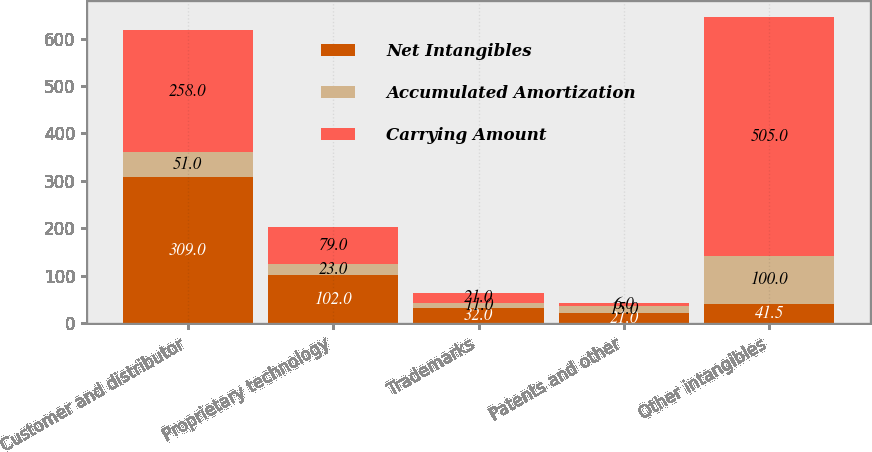Convert chart. <chart><loc_0><loc_0><loc_500><loc_500><stacked_bar_chart><ecel><fcel>Customer and distributor<fcel>Proprietary technology<fcel>Trademarks<fcel>Patents and other<fcel>Other intangibles<nl><fcel>Net Intangibles<fcel>309<fcel>102<fcel>32<fcel>21<fcel>41.5<nl><fcel>Accumulated Amortization<fcel>51<fcel>23<fcel>11<fcel>15<fcel>100<nl><fcel>Carrying Amount<fcel>258<fcel>79<fcel>21<fcel>6<fcel>505<nl></chart> 